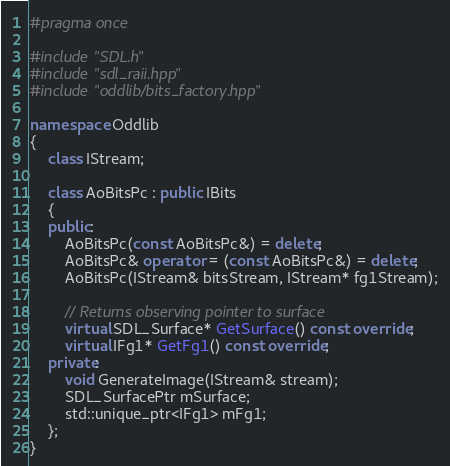Convert code to text. <code><loc_0><loc_0><loc_500><loc_500><_C++_>#pragma once

#include "SDL.h"
#include "sdl_raii.hpp"
#include "oddlib/bits_factory.hpp"

namespace Oddlib
{
    class IStream;

    class AoBitsPc : public IBits
    {
    public:
        AoBitsPc(const AoBitsPc&) = delete;
        AoBitsPc& operator = (const AoBitsPc&) = delete;
        AoBitsPc(IStream& bitsStream, IStream* fg1Stream);

        // Returns observing pointer to surface
        virtual SDL_Surface* GetSurface() const override;
        virtual IFg1* GetFg1() const override;
    private:
        void GenerateImage(IStream& stream);
        SDL_SurfacePtr mSurface;
        std::unique_ptr<IFg1> mFg1;
    };
}</code> 